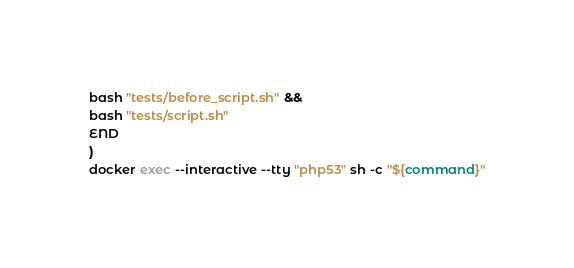Convert code to text. <code><loc_0><loc_0><loc_500><loc_500><_Bash_>bash "tests/before_script.sh" &&
bash "tests/script.sh"
END
)
docker exec --interactive --tty "php53" sh -c "${command}"
</code> 